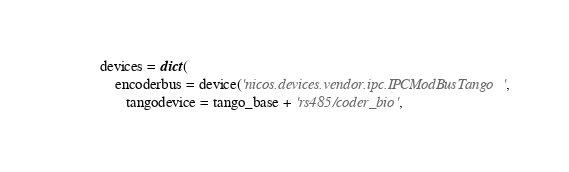Convert code to text. <code><loc_0><loc_0><loc_500><loc_500><_Python_>devices = dict(
    encoderbus = device('nicos.devices.vendor.ipc.IPCModBusTango',
       tangodevice = tango_base + 'rs485/coder_bio',</code> 